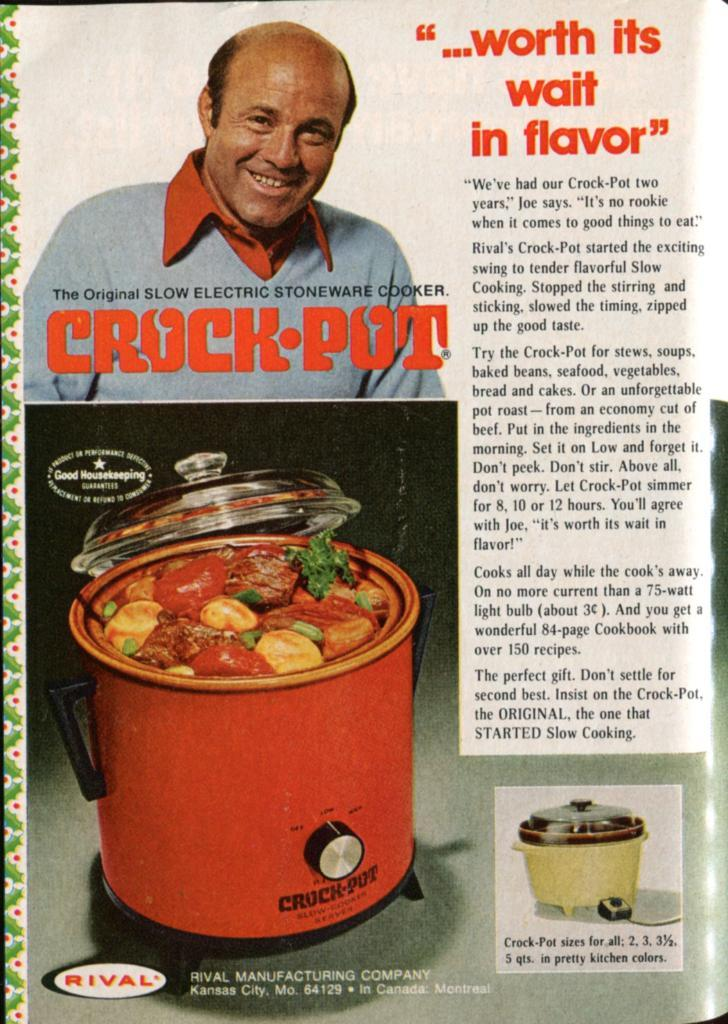<image>
Give a short and clear explanation of the subsequent image. An old advertisement for a Crock pot by Rival Manufacturing Company. The ad says it's "worth its wait in flavor". 